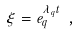<formula> <loc_0><loc_0><loc_500><loc_500>\xi = e ^ { \lambda _ { q } t } _ { q } \ ,</formula> 